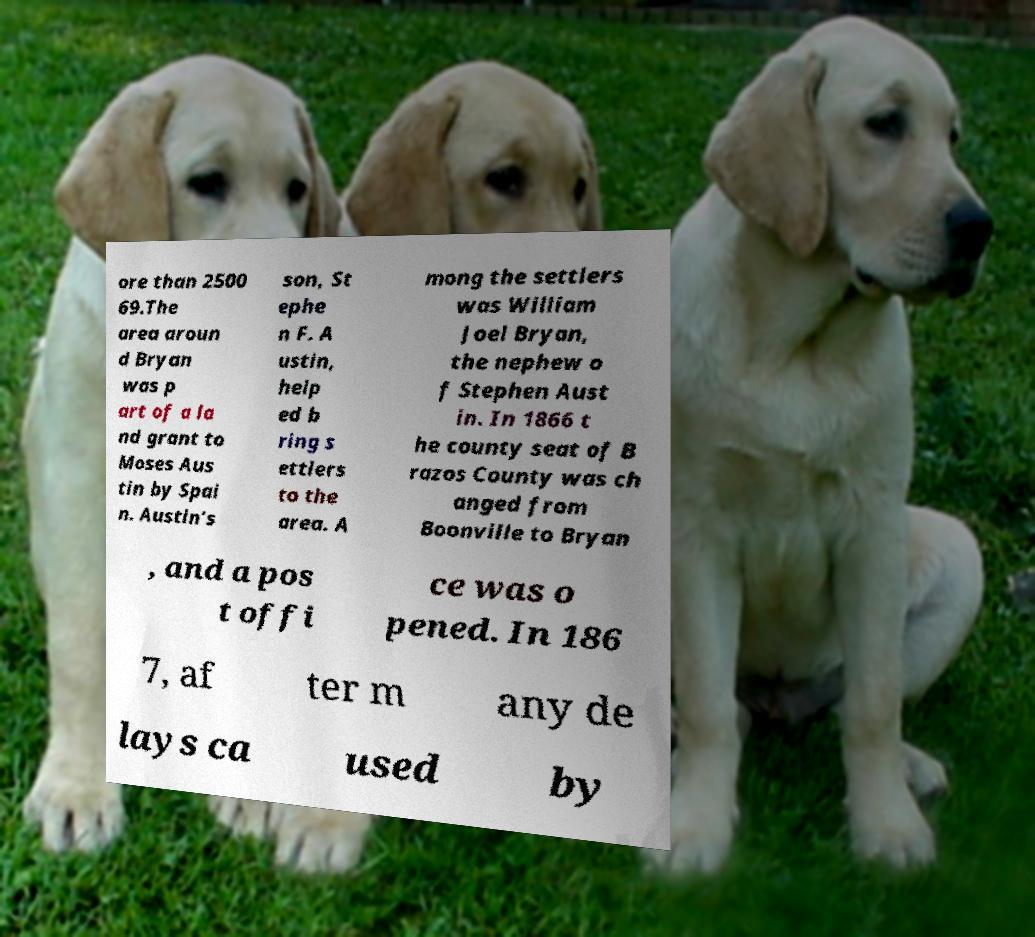Could you assist in decoding the text presented in this image and type it out clearly? ore than 2500 69.The area aroun d Bryan was p art of a la nd grant to Moses Aus tin by Spai n. Austin's son, St ephe n F. A ustin, help ed b ring s ettlers to the area. A mong the settlers was William Joel Bryan, the nephew o f Stephen Aust in. In 1866 t he county seat of B razos County was ch anged from Boonville to Bryan , and a pos t offi ce was o pened. In 186 7, af ter m any de lays ca used by 